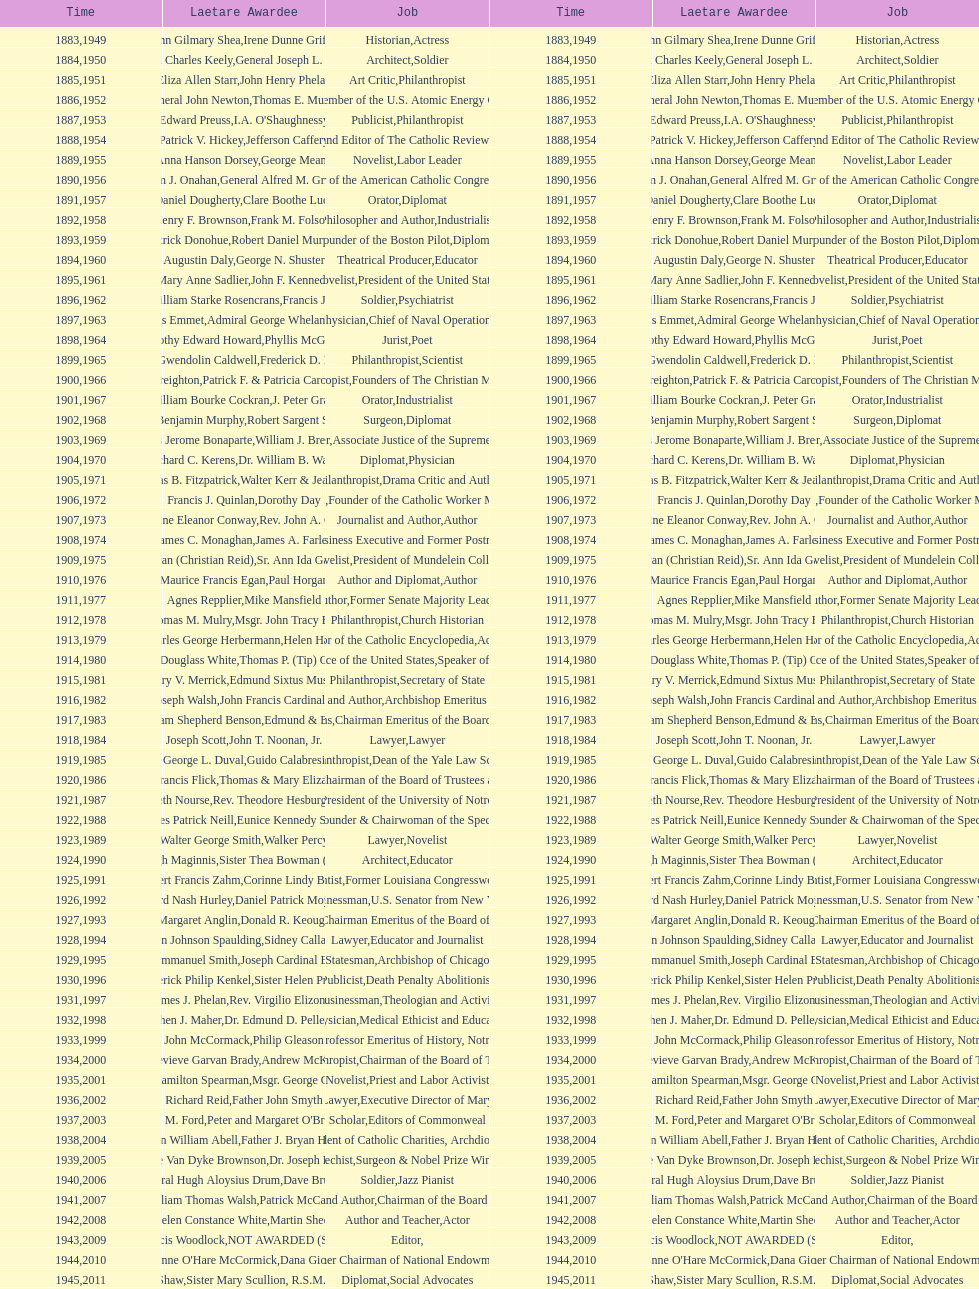What are the total number of times soldier is listed as the position on this chart? 4. 